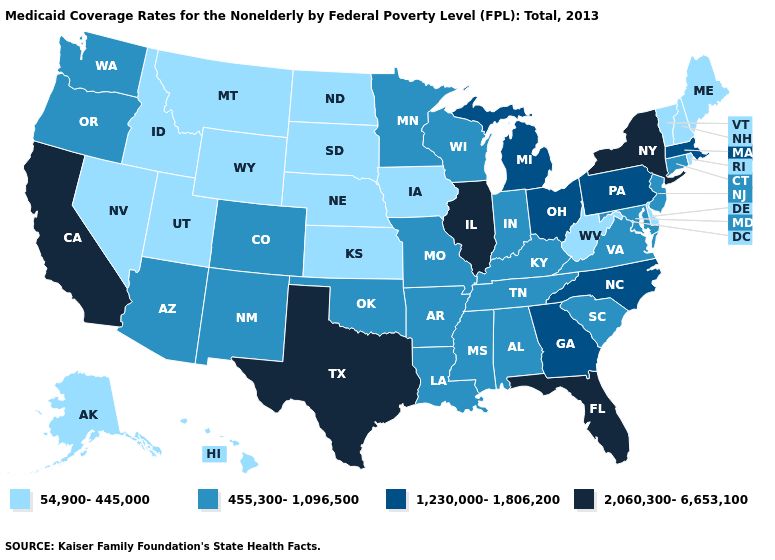Name the states that have a value in the range 2,060,300-6,653,100?
Answer briefly. California, Florida, Illinois, New York, Texas. Among the states that border Utah , which have the lowest value?
Keep it brief. Idaho, Nevada, Wyoming. Name the states that have a value in the range 455,300-1,096,500?
Write a very short answer. Alabama, Arizona, Arkansas, Colorado, Connecticut, Indiana, Kentucky, Louisiana, Maryland, Minnesota, Mississippi, Missouri, New Jersey, New Mexico, Oklahoma, Oregon, South Carolina, Tennessee, Virginia, Washington, Wisconsin. How many symbols are there in the legend?
Short answer required. 4. What is the value of Pennsylvania?
Be succinct. 1,230,000-1,806,200. Does New Jersey have the highest value in the Northeast?
Short answer required. No. Name the states that have a value in the range 455,300-1,096,500?
Concise answer only. Alabama, Arizona, Arkansas, Colorado, Connecticut, Indiana, Kentucky, Louisiana, Maryland, Minnesota, Mississippi, Missouri, New Jersey, New Mexico, Oklahoma, Oregon, South Carolina, Tennessee, Virginia, Washington, Wisconsin. Is the legend a continuous bar?
Quick response, please. No. What is the value of New York?
Write a very short answer. 2,060,300-6,653,100. Name the states that have a value in the range 1,230,000-1,806,200?
Short answer required. Georgia, Massachusetts, Michigan, North Carolina, Ohio, Pennsylvania. Name the states that have a value in the range 54,900-445,000?
Concise answer only. Alaska, Delaware, Hawaii, Idaho, Iowa, Kansas, Maine, Montana, Nebraska, Nevada, New Hampshire, North Dakota, Rhode Island, South Dakota, Utah, Vermont, West Virginia, Wyoming. Does the map have missing data?
Give a very brief answer. No. Does Washington have the lowest value in the West?
Keep it brief. No. What is the value of Alaska?
Write a very short answer. 54,900-445,000. Does the map have missing data?
Concise answer only. No. 